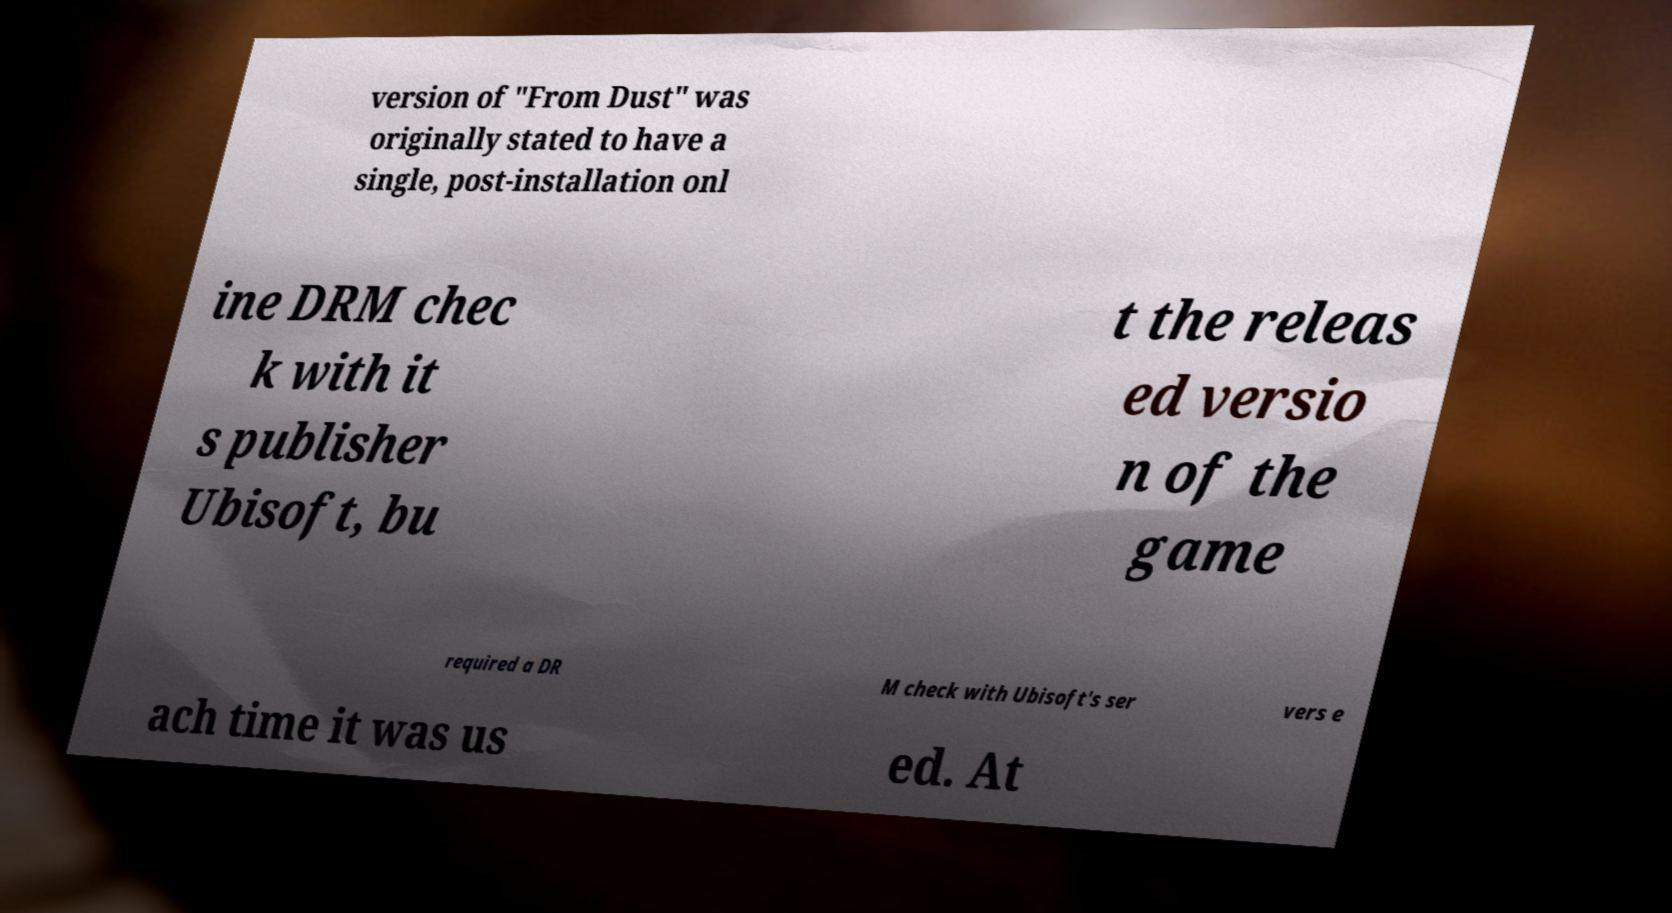For documentation purposes, I need the text within this image transcribed. Could you provide that? version of "From Dust" was originally stated to have a single, post-installation onl ine DRM chec k with it s publisher Ubisoft, bu t the releas ed versio n of the game required a DR M check with Ubisoft's ser vers e ach time it was us ed. At 